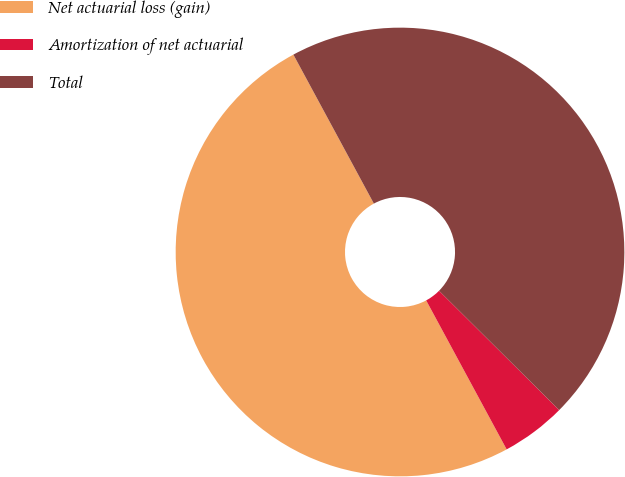<chart> <loc_0><loc_0><loc_500><loc_500><pie_chart><fcel>Net actuarial loss (gain)<fcel>Amortization of net actuarial<fcel>Total<nl><fcel>50.0%<fcel>4.67%<fcel>45.33%<nl></chart> 